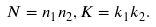<formula> <loc_0><loc_0><loc_500><loc_500>N = n _ { 1 } n _ { 2 } , K = k _ { 1 } k _ { 2 } .</formula> 